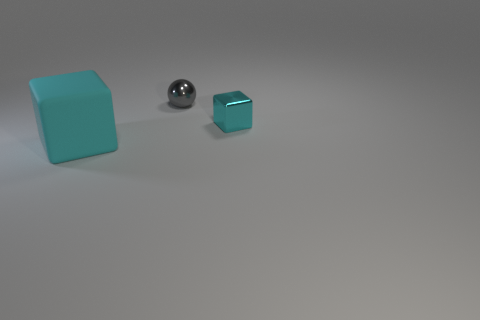Add 1 cyan things. How many objects exist? 4 Subtract all balls. How many objects are left? 2 Subtract all small metallic balls. Subtract all red rubber spheres. How many objects are left? 2 Add 2 big cyan matte blocks. How many big cyan matte blocks are left? 3 Add 1 big brown spheres. How many big brown spheres exist? 1 Subtract 0 blue spheres. How many objects are left? 3 